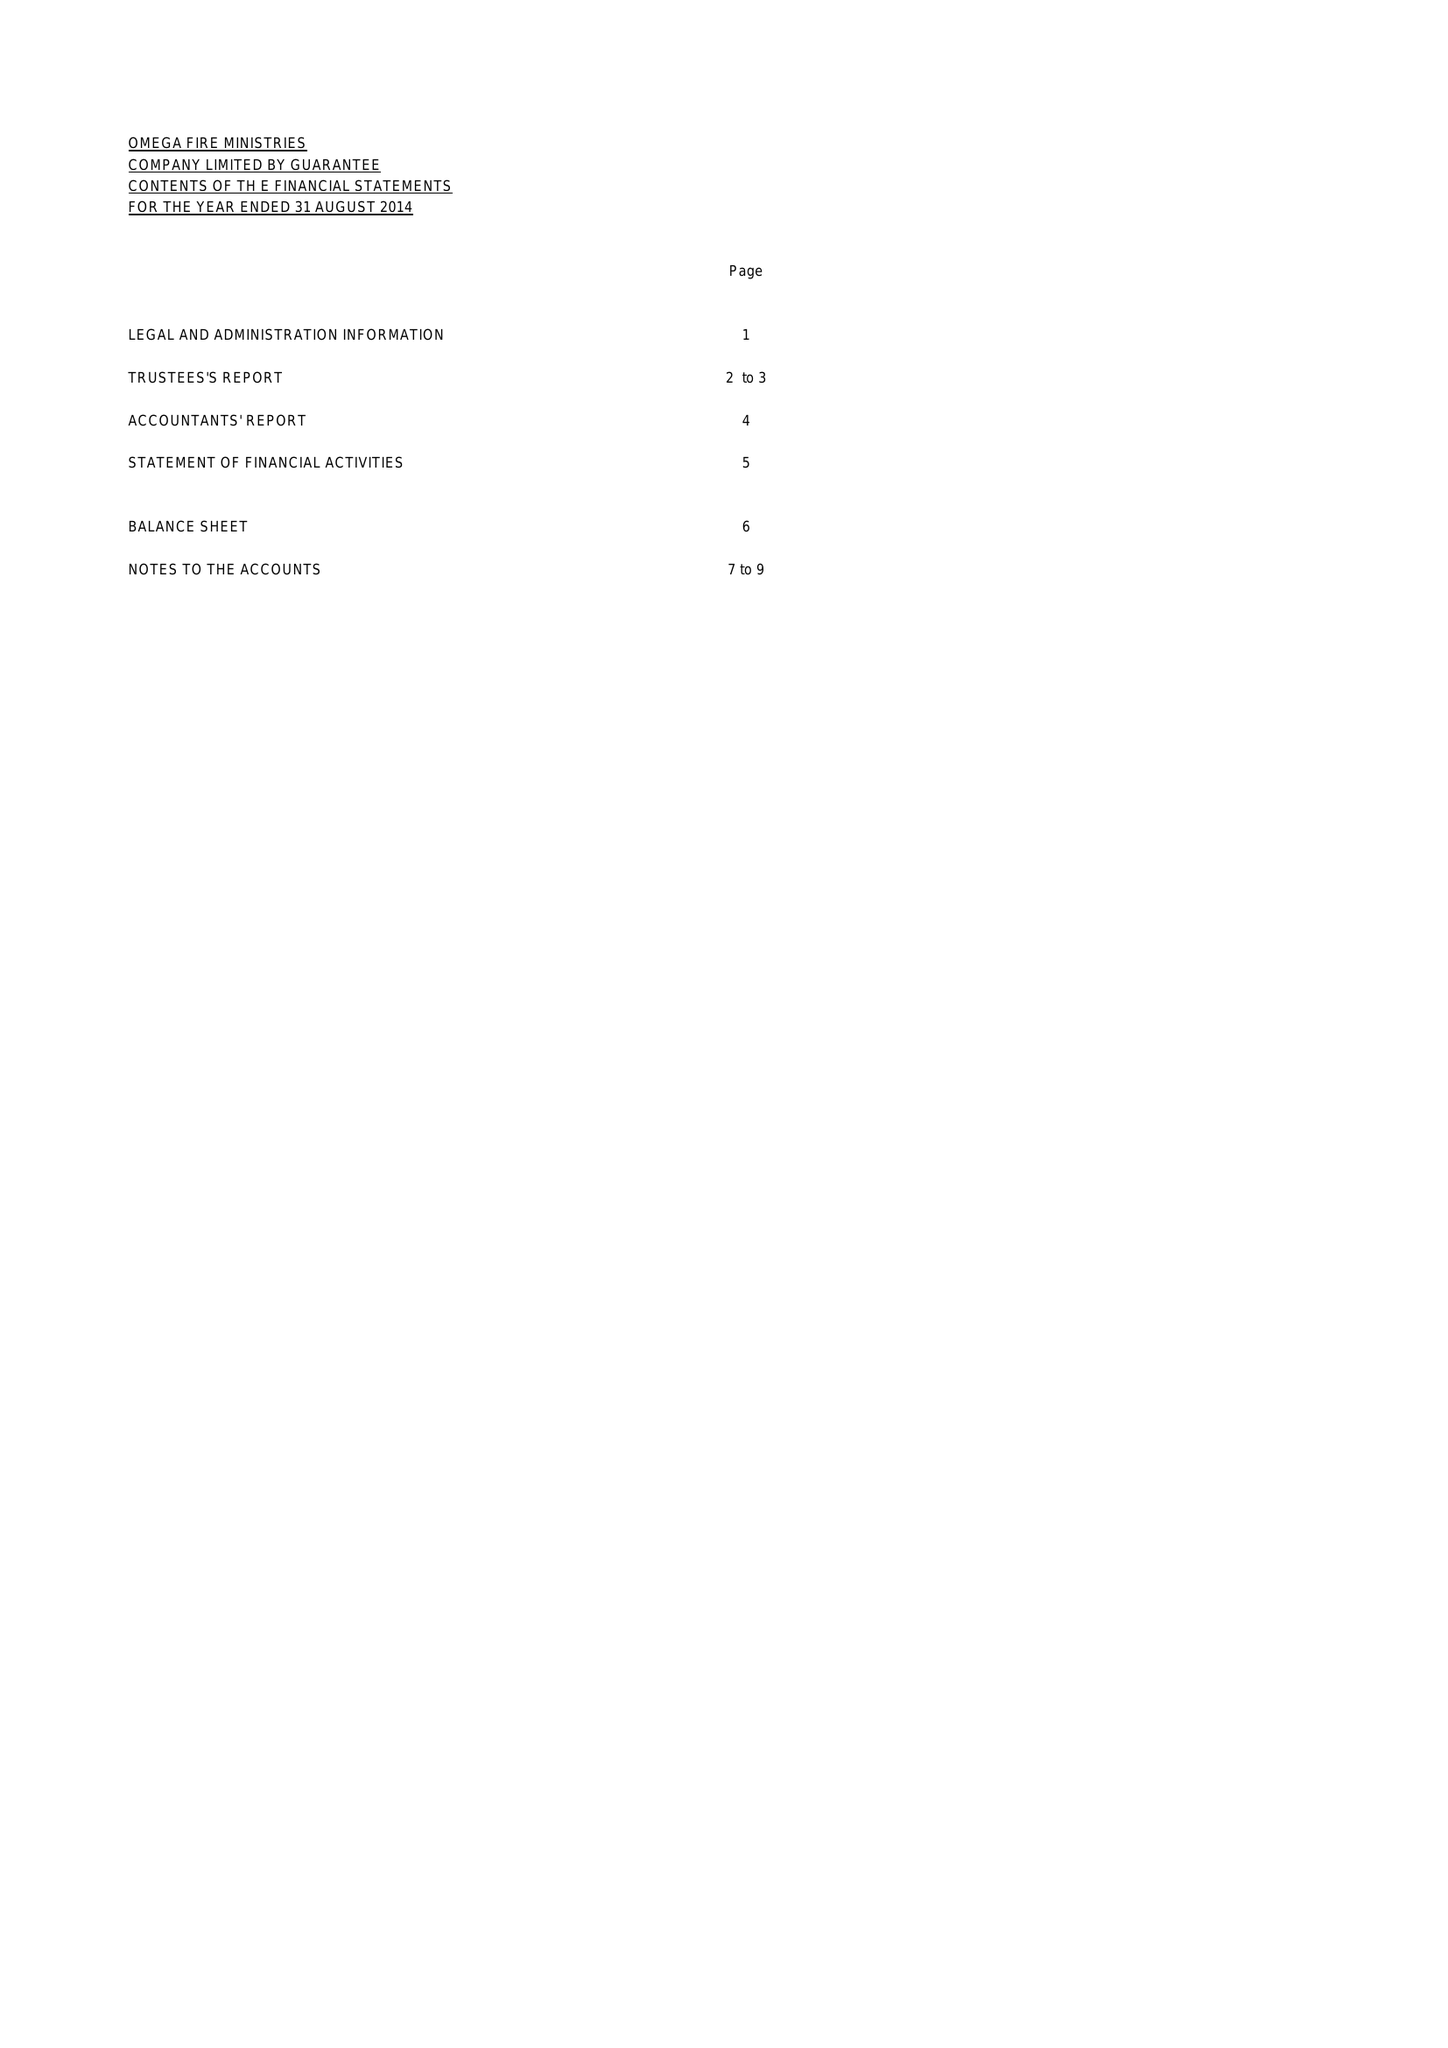What is the value for the charity_name?
Answer the question using a single word or phrase. Omega Fire Ministries 